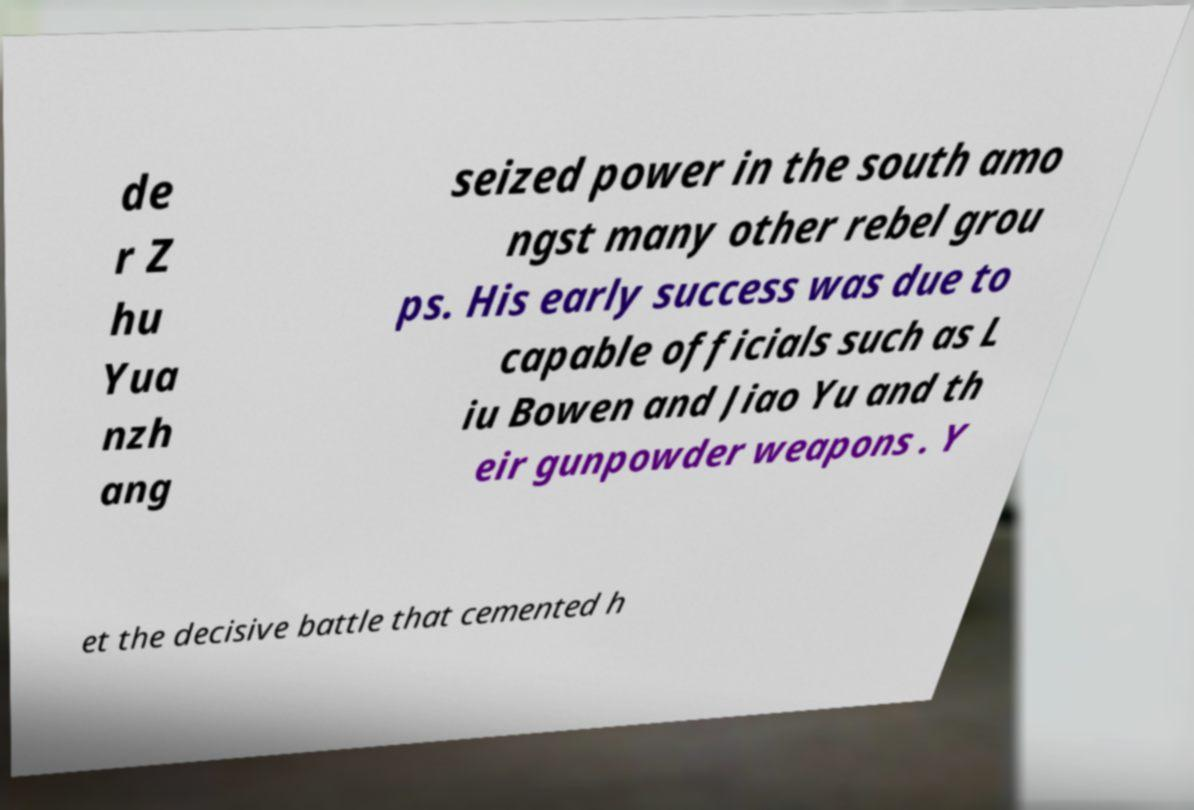What messages or text are displayed in this image? I need them in a readable, typed format. de r Z hu Yua nzh ang seized power in the south amo ngst many other rebel grou ps. His early success was due to capable officials such as L iu Bowen and Jiao Yu and th eir gunpowder weapons . Y et the decisive battle that cemented h 